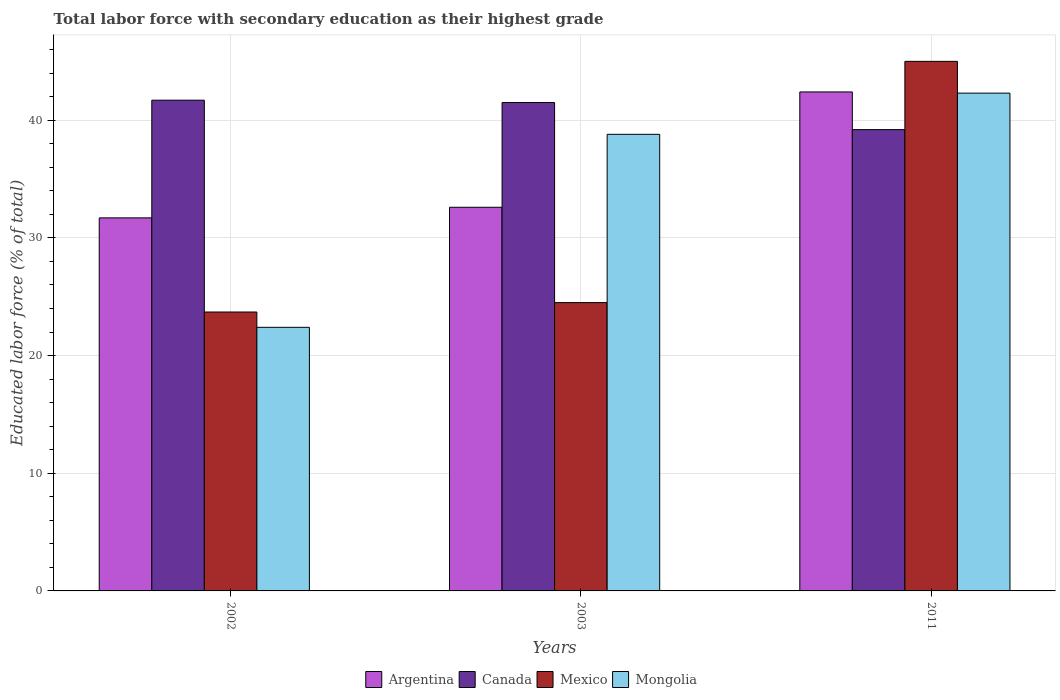How many groups of bars are there?
Offer a terse response. 3. How many bars are there on the 3rd tick from the right?
Make the answer very short. 4. What is the percentage of total labor force with primary education in Mongolia in 2003?
Provide a short and direct response. 38.8. Across all years, what is the maximum percentage of total labor force with primary education in Canada?
Your answer should be very brief. 41.7. Across all years, what is the minimum percentage of total labor force with primary education in Argentina?
Provide a short and direct response. 31.7. In which year was the percentage of total labor force with primary education in Mongolia maximum?
Offer a very short reply. 2011. What is the total percentage of total labor force with primary education in Canada in the graph?
Make the answer very short. 122.4. What is the difference between the percentage of total labor force with primary education in Argentina in 2002 and that in 2003?
Your response must be concise. -0.9. What is the difference between the percentage of total labor force with primary education in Mexico in 2011 and the percentage of total labor force with primary education in Argentina in 2002?
Offer a very short reply. 13.3. What is the average percentage of total labor force with primary education in Mexico per year?
Provide a short and direct response. 31.07. In the year 2002, what is the difference between the percentage of total labor force with primary education in Canada and percentage of total labor force with primary education in Mongolia?
Give a very brief answer. 19.3. What is the ratio of the percentage of total labor force with primary education in Canada in 2002 to that in 2011?
Your answer should be compact. 1.06. Is the percentage of total labor force with primary education in Canada in 2002 less than that in 2011?
Your response must be concise. No. Is the difference between the percentage of total labor force with primary education in Canada in 2002 and 2003 greater than the difference between the percentage of total labor force with primary education in Mongolia in 2002 and 2003?
Give a very brief answer. Yes. What is the difference between the highest and the second highest percentage of total labor force with primary education in Canada?
Make the answer very short. 0.2. What is the difference between the highest and the lowest percentage of total labor force with primary education in Mongolia?
Your response must be concise. 19.9. Is the sum of the percentage of total labor force with primary education in Mexico in 2002 and 2003 greater than the maximum percentage of total labor force with primary education in Argentina across all years?
Your answer should be very brief. Yes. What does the 4th bar from the left in 2011 represents?
Your answer should be very brief. Mongolia. Are all the bars in the graph horizontal?
Your answer should be very brief. No. How many years are there in the graph?
Offer a very short reply. 3. Are the values on the major ticks of Y-axis written in scientific E-notation?
Your answer should be compact. No. How many legend labels are there?
Make the answer very short. 4. What is the title of the graph?
Your answer should be very brief. Total labor force with secondary education as their highest grade. Does "Mexico" appear as one of the legend labels in the graph?
Offer a very short reply. Yes. What is the label or title of the Y-axis?
Offer a very short reply. Educated labor force (% of total). What is the Educated labor force (% of total) in Argentina in 2002?
Make the answer very short. 31.7. What is the Educated labor force (% of total) in Canada in 2002?
Offer a very short reply. 41.7. What is the Educated labor force (% of total) in Mexico in 2002?
Your answer should be very brief. 23.7. What is the Educated labor force (% of total) in Mongolia in 2002?
Offer a terse response. 22.4. What is the Educated labor force (% of total) in Argentina in 2003?
Keep it short and to the point. 32.6. What is the Educated labor force (% of total) in Canada in 2003?
Make the answer very short. 41.5. What is the Educated labor force (% of total) in Mongolia in 2003?
Keep it short and to the point. 38.8. What is the Educated labor force (% of total) in Argentina in 2011?
Provide a short and direct response. 42.4. What is the Educated labor force (% of total) of Canada in 2011?
Offer a terse response. 39.2. What is the Educated labor force (% of total) of Mexico in 2011?
Provide a succinct answer. 45. What is the Educated labor force (% of total) in Mongolia in 2011?
Ensure brevity in your answer.  42.3. Across all years, what is the maximum Educated labor force (% of total) in Argentina?
Provide a short and direct response. 42.4. Across all years, what is the maximum Educated labor force (% of total) of Canada?
Your answer should be compact. 41.7. Across all years, what is the maximum Educated labor force (% of total) in Mongolia?
Give a very brief answer. 42.3. Across all years, what is the minimum Educated labor force (% of total) in Argentina?
Make the answer very short. 31.7. Across all years, what is the minimum Educated labor force (% of total) of Canada?
Your answer should be compact. 39.2. Across all years, what is the minimum Educated labor force (% of total) of Mexico?
Give a very brief answer. 23.7. Across all years, what is the minimum Educated labor force (% of total) of Mongolia?
Give a very brief answer. 22.4. What is the total Educated labor force (% of total) in Argentina in the graph?
Make the answer very short. 106.7. What is the total Educated labor force (% of total) of Canada in the graph?
Provide a short and direct response. 122.4. What is the total Educated labor force (% of total) in Mexico in the graph?
Your answer should be very brief. 93.2. What is the total Educated labor force (% of total) of Mongolia in the graph?
Give a very brief answer. 103.5. What is the difference between the Educated labor force (% of total) of Mexico in 2002 and that in 2003?
Your response must be concise. -0.8. What is the difference between the Educated labor force (% of total) in Mongolia in 2002 and that in 2003?
Your answer should be very brief. -16.4. What is the difference between the Educated labor force (% of total) of Argentina in 2002 and that in 2011?
Ensure brevity in your answer.  -10.7. What is the difference between the Educated labor force (% of total) in Mexico in 2002 and that in 2011?
Provide a succinct answer. -21.3. What is the difference between the Educated labor force (% of total) in Mongolia in 2002 and that in 2011?
Your response must be concise. -19.9. What is the difference between the Educated labor force (% of total) of Canada in 2003 and that in 2011?
Offer a terse response. 2.3. What is the difference between the Educated labor force (% of total) in Mexico in 2003 and that in 2011?
Your response must be concise. -20.5. What is the difference between the Educated labor force (% of total) of Argentina in 2002 and the Educated labor force (% of total) of Mexico in 2003?
Make the answer very short. 7.2. What is the difference between the Educated labor force (% of total) of Canada in 2002 and the Educated labor force (% of total) of Mexico in 2003?
Offer a terse response. 17.2. What is the difference between the Educated labor force (% of total) of Canada in 2002 and the Educated labor force (% of total) of Mongolia in 2003?
Your response must be concise. 2.9. What is the difference between the Educated labor force (% of total) in Mexico in 2002 and the Educated labor force (% of total) in Mongolia in 2003?
Offer a very short reply. -15.1. What is the difference between the Educated labor force (% of total) of Argentina in 2002 and the Educated labor force (% of total) of Mexico in 2011?
Ensure brevity in your answer.  -13.3. What is the difference between the Educated labor force (% of total) of Argentina in 2002 and the Educated labor force (% of total) of Mongolia in 2011?
Make the answer very short. -10.6. What is the difference between the Educated labor force (% of total) of Canada in 2002 and the Educated labor force (% of total) of Mexico in 2011?
Give a very brief answer. -3.3. What is the difference between the Educated labor force (% of total) in Mexico in 2002 and the Educated labor force (% of total) in Mongolia in 2011?
Offer a very short reply. -18.6. What is the difference between the Educated labor force (% of total) in Argentina in 2003 and the Educated labor force (% of total) in Mongolia in 2011?
Make the answer very short. -9.7. What is the difference between the Educated labor force (% of total) of Canada in 2003 and the Educated labor force (% of total) of Mongolia in 2011?
Your answer should be compact. -0.8. What is the difference between the Educated labor force (% of total) of Mexico in 2003 and the Educated labor force (% of total) of Mongolia in 2011?
Provide a short and direct response. -17.8. What is the average Educated labor force (% of total) of Argentina per year?
Keep it short and to the point. 35.57. What is the average Educated labor force (% of total) of Canada per year?
Make the answer very short. 40.8. What is the average Educated labor force (% of total) in Mexico per year?
Your answer should be compact. 31.07. What is the average Educated labor force (% of total) of Mongolia per year?
Provide a short and direct response. 34.5. In the year 2002, what is the difference between the Educated labor force (% of total) of Canada and Educated labor force (% of total) of Mexico?
Make the answer very short. 18. In the year 2002, what is the difference between the Educated labor force (% of total) in Canada and Educated labor force (% of total) in Mongolia?
Keep it short and to the point. 19.3. In the year 2003, what is the difference between the Educated labor force (% of total) of Argentina and Educated labor force (% of total) of Mongolia?
Your answer should be compact. -6.2. In the year 2003, what is the difference between the Educated labor force (% of total) of Mexico and Educated labor force (% of total) of Mongolia?
Provide a short and direct response. -14.3. In the year 2011, what is the difference between the Educated labor force (% of total) in Argentina and Educated labor force (% of total) in Mexico?
Offer a terse response. -2.6. In the year 2011, what is the difference between the Educated labor force (% of total) of Canada and Educated labor force (% of total) of Mexico?
Your answer should be very brief. -5.8. What is the ratio of the Educated labor force (% of total) of Argentina in 2002 to that in 2003?
Provide a short and direct response. 0.97. What is the ratio of the Educated labor force (% of total) of Canada in 2002 to that in 2003?
Give a very brief answer. 1. What is the ratio of the Educated labor force (% of total) in Mexico in 2002 to that in 2003?
Give a very brief answer. 0.97. What is the ratio of the Educated labor force (% of total) in Mongolia in 2002 to that in 2003?
Your response must be concise. 0.58. What is the ratio of the Educated labor force (% of total) in Argentina in 2002 to that in 2011?
Make the answer very short. 0.75. What is the ratio of the Educated labor force (% of total) of Canada in 2002 to that in 2011?
Offer a terse response. 1.06. What is the ratio of the Educated labor force (% of total) of Mexico in 2002 to that in 2011?
Provide a short and direct response. 0.53. What is the ratio of the Educated labor force (% of total) in Mongolia in 2002 to that in 2011?
Keep it short and to the point. 0.53. What is the ratio of the Educated labor force (% of total) in Argentina in 2003 to that in 2011?
Your response must be concise. 0.77. What is the ratio of the Educated labor force (% of total) in Canada in 2003 to that in 2011?
Ensure brevity in your answer.  1.06. What is the ratio of the Educated labor force (% of total) in Mexico in 2003 to that in 2011?
Your answer should be very brief. 0.54. What is the ratio of the Educated labor force (% of total) in Mongolia in 2003 to that in 2011?
Ensure brevity in your answer.  0.92. What is the difference between the highest and the second highest Educated labor force (% of total) in Argentina?
Offer a very short reply. 9.8. What is the difference between the highest and the second highest Educated labor force (% of total) in Canada?
Provide a short and direct response. 0.2. What is the difference between the highest and the second highest Educated labor force (% of total) in Mexico?
Your response must be concise. 20.5. What is the difference between the highest and the second highest Educated labor force (% of total) in Mongolia?
Provide a short and direct response. 3.5. What is the difference between the highest and the lowest Educated labor force (% of total) of Mexico?
Provide a succinct answer. 21.3. What is the difference between the highest and the lowest Educated labor force (% of total) in Mongolia?
Your response must be concise. 19.9. 